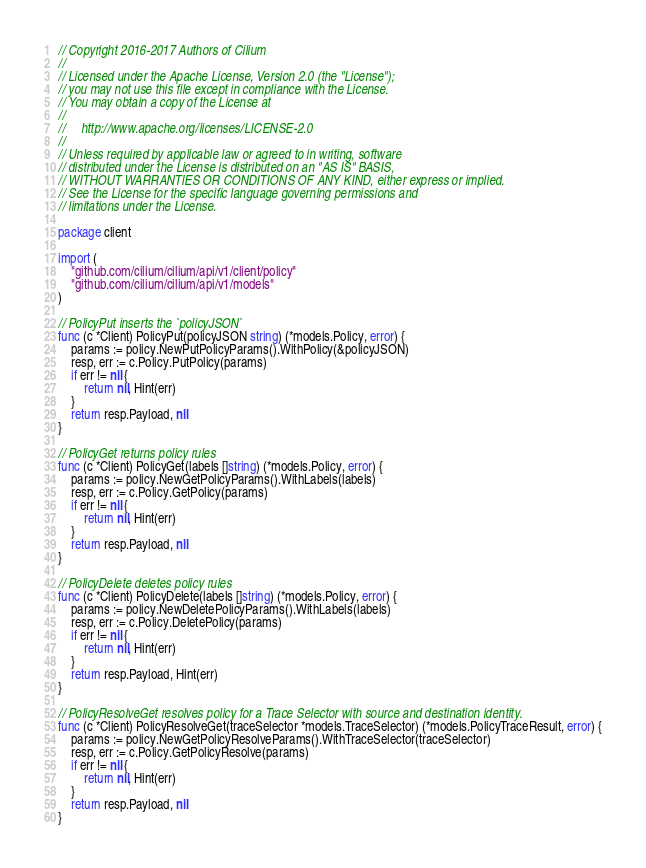Convert code to text. <code><loc_0><loc_0><loc_500><loc_500><_Go_>// Copyright 2016-2017 Authors of Cilium
//
// Licensed under the Apache License, Version 2.0 (the "License");
// you may not use this file except in compliance with the License.
// You may obtain a copy of the License at
//
//     http://www.apache.org/licenses/LICENSE-2.0
//
// Unless required by applicable law or agreed to in writing, software
// distributed under the License is distributed on an "AS IS" BASIS,
// WITHOUT WARRANTIES OR CONDITIONS OF ANY KIND, either express or implied.
// See the License for the specific language governing permissions and
// limitations under the License.

package client

import (
	"github.com/cilium/cilium/api/v1/client/policy"
	"github.com/cilium/cilium/api/v1/models"
)

// PolicyPut inserts the `policyJSON`
func (c *Client) PolicyPut(policyJSON string) (*models.Policy, error) {
	params := policy.NewPutPolicyParams().WithPolicy(&policyJSON)
	resp, err := c.Policy.PutPolicy(params)
	if err != nil {
		return nil, Hint(err)
	}
	return resp.Payload, nil
}

// PolicyGet returns policy rules
func (c *Client) PolicyGet(labels []string) (*models.Policy, error) {
	params := policy.NewGetPolicyParams().WithLabels(labels)
	resp, err := c.Policy.GetPolicy(params)
	if err != nil {
		return nil, Hint(err)
	}
	return resp.Payload, nil
}

// PolicyDelete deletes policy rules
func (c *Client) PolicyDelete(labels []string) (*models.Policy, error) {
	params := policy.NewDeletePolicyParams().WithLabels(labels)
	resp, err := c.Policy.DeletePolicy(params)
	if err != nil {
		return nil, Hint(err)
	}
	return resp.Payload, Hint(err)
}

// PolicyResolveGet resolves policy for a Trace Selector with source and destination identity.
func (c *Client) PolicyResolveGet(traceSelector *models.TraceSelector) (*models.PolicyTraceResult, error) {
	params := policy.NewGetPolicyResolveParams().WithTraceSelector(traceSelector)
	resp, err := c.Policy.GetPolicyResolve(params)
	if err != nil {
		return nil, Hint(err)
	}
	return resp.Payload, nil
}
</code> 